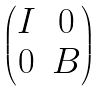<formula> <loc_0><loc_0><loc_500><loc_500>\begin{pmatrix} I & 0 \\ 0 & B \end{pmatrix}</formula> 